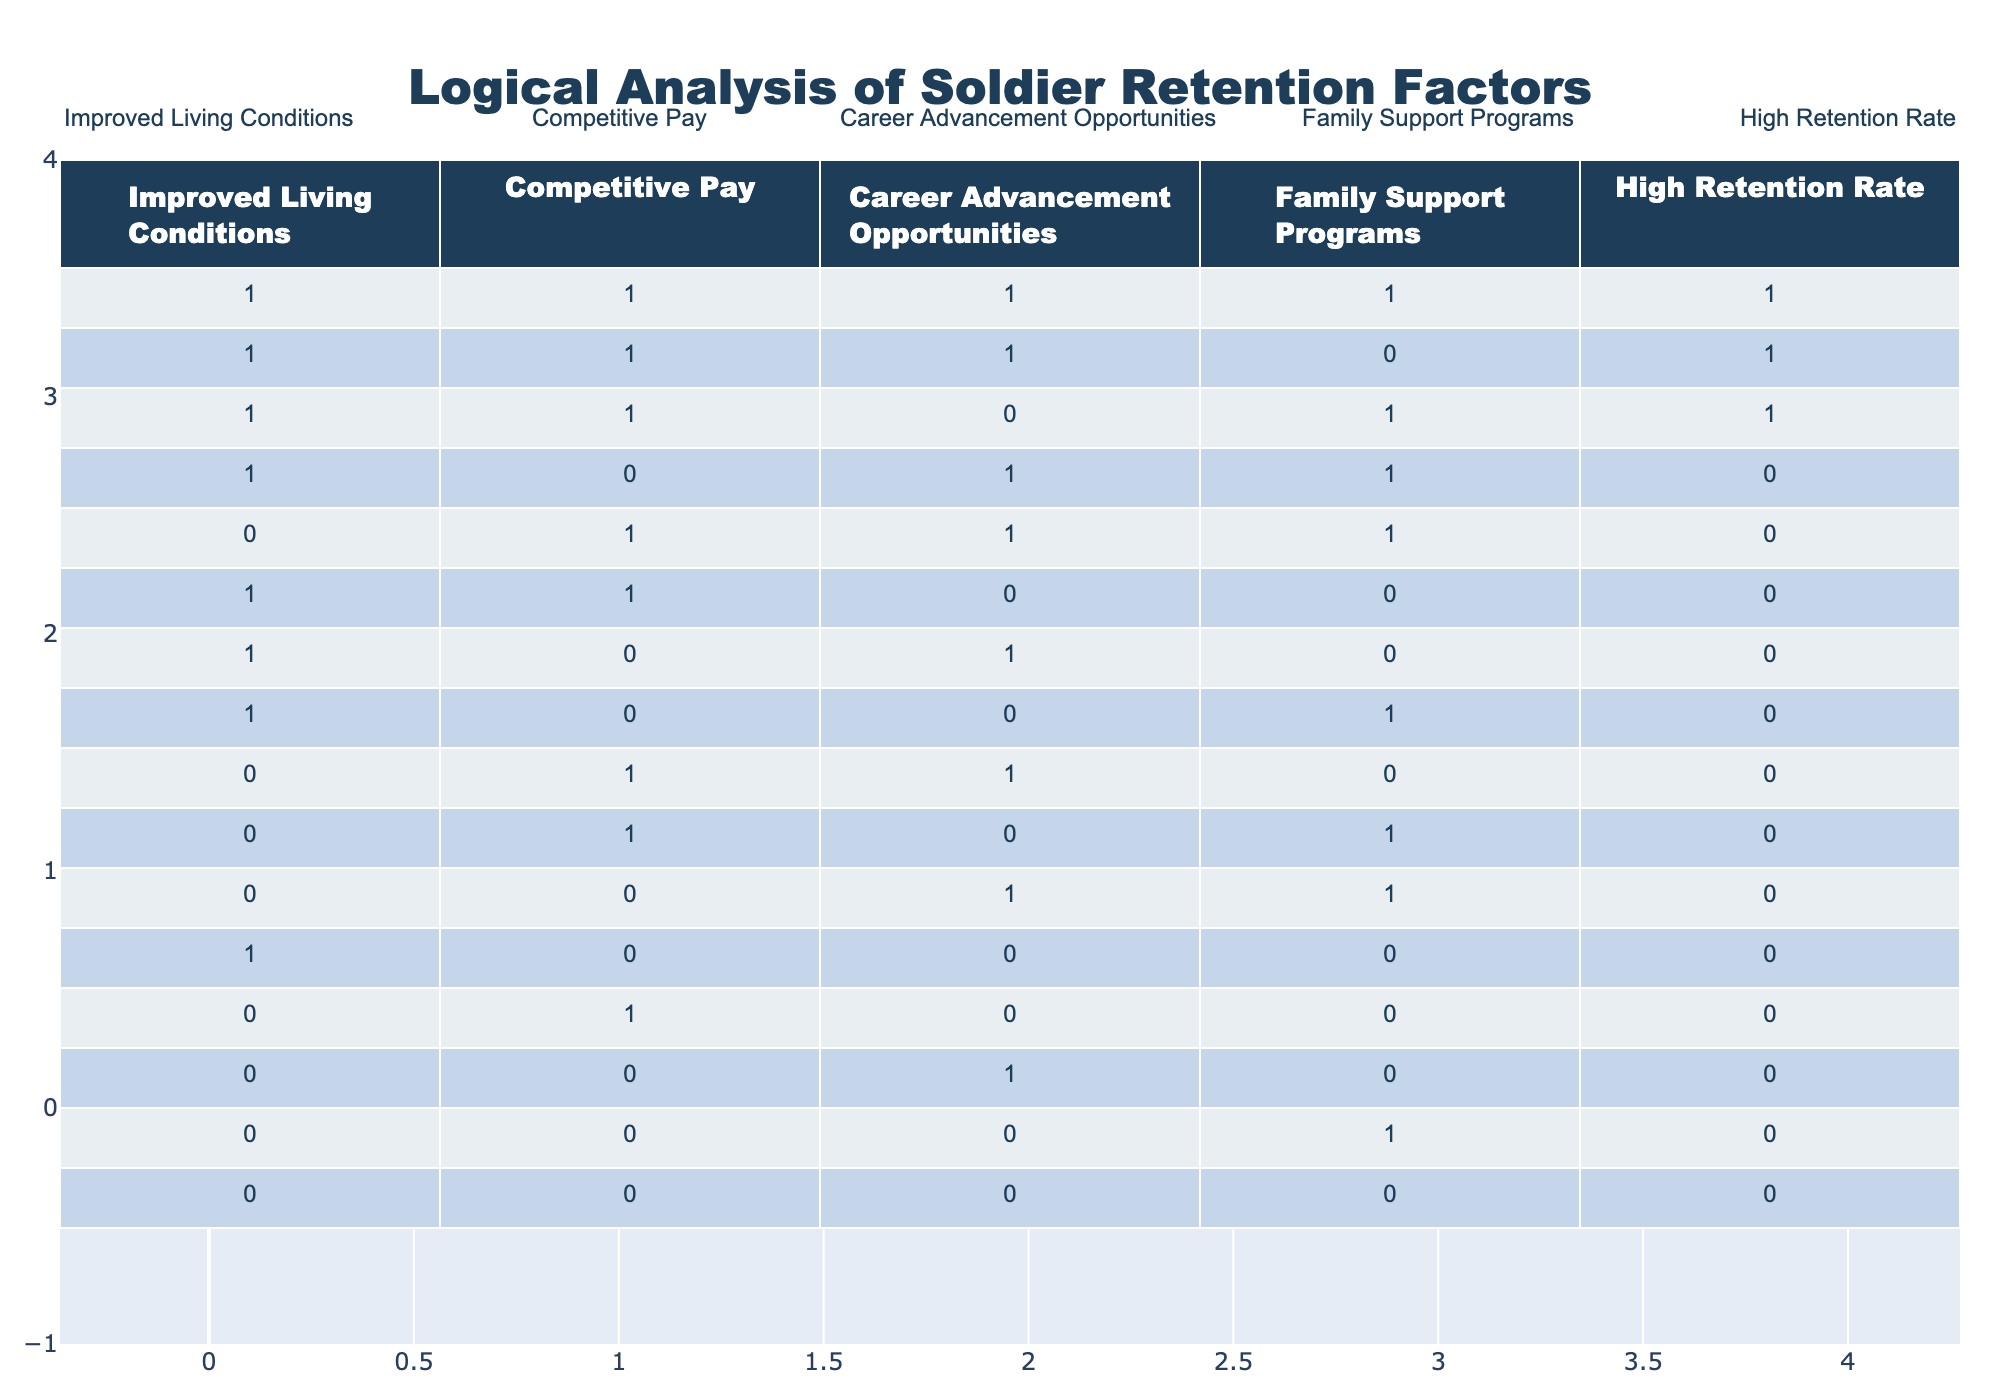What is the retention rate when living conditions, pay, and career advancement opportunities are all high? When living conditions, pay, and career advancement opportunities are all marked as 1 (high), we can see from the table that the retention rate is 1 in this scenario. There is one row in the table that meets this condition, where all three factors are 1, leading to a retention rate of 1.
Answer: 1 How many unique configurations of soldier retention factors result in a high retention rate? To find unique configurations leading to a high retention rate, we look at the rows with a retention rate of 1. There are a total of three unique combinations (in the first three rows): (1, 1, 1, 1), (1, 1, 1, 0), and (1, 1, 0, 1). Thus, the answer is three.
Answer: 3 Is there any scenario where only family support programs are prioritized without the other factors leading to high retention? Looking at the table, we can see there is no scenario where family support programs are prioritized (marked as 1) while the other factors are all marked as 0 leading to high retention. Therefore, the answer is no.
Answer: No What is the average retention rate for configurations where pay is competitive? When pay is competitive (marked as 1), there are six data points (rows 1, 5, 6, 8, 9, 12). The retention rates from these rows are 1, 0, 0, 0, 0, 0. The sum of retention rates is 1 + 0 + 0 + 0 + 0 + 0 = 1. Since there are 6 configurations, the average retention rate is 1/6, which simplifies to approximately 0.17.
Answer: 0.17 Can we conclude that improved living conditions always lead to a high retention rate based on the table? Across the configurations where improved living conditions are marked as 1, there are several outcomes regarding retention rates (3 out of 8 scenarios end with a retention rate of 1). This indicates that improved living conditions alone do not guarantee high retention rates as other factors must also come into play.
Answer: No 